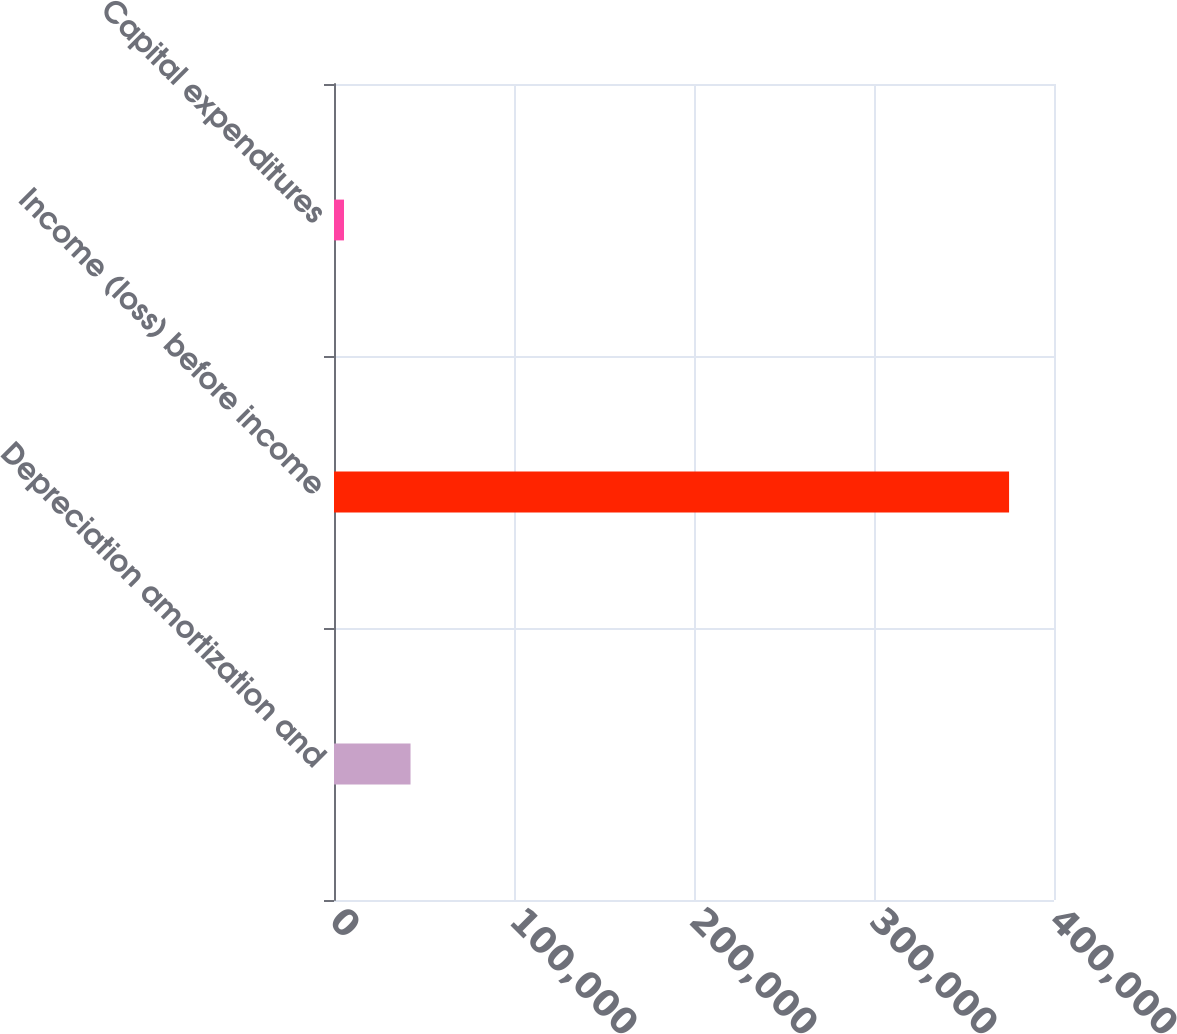Convert chart. <chart><loc_0><loc_0><loc_500><loc_500><bar_chart><fcel>Depreciation amortization and<fcel>Income (loss) before income<fcel>Capital expenditures<nl><fcel>42519<fcel>375042<fcel>5572<nl></chart> 